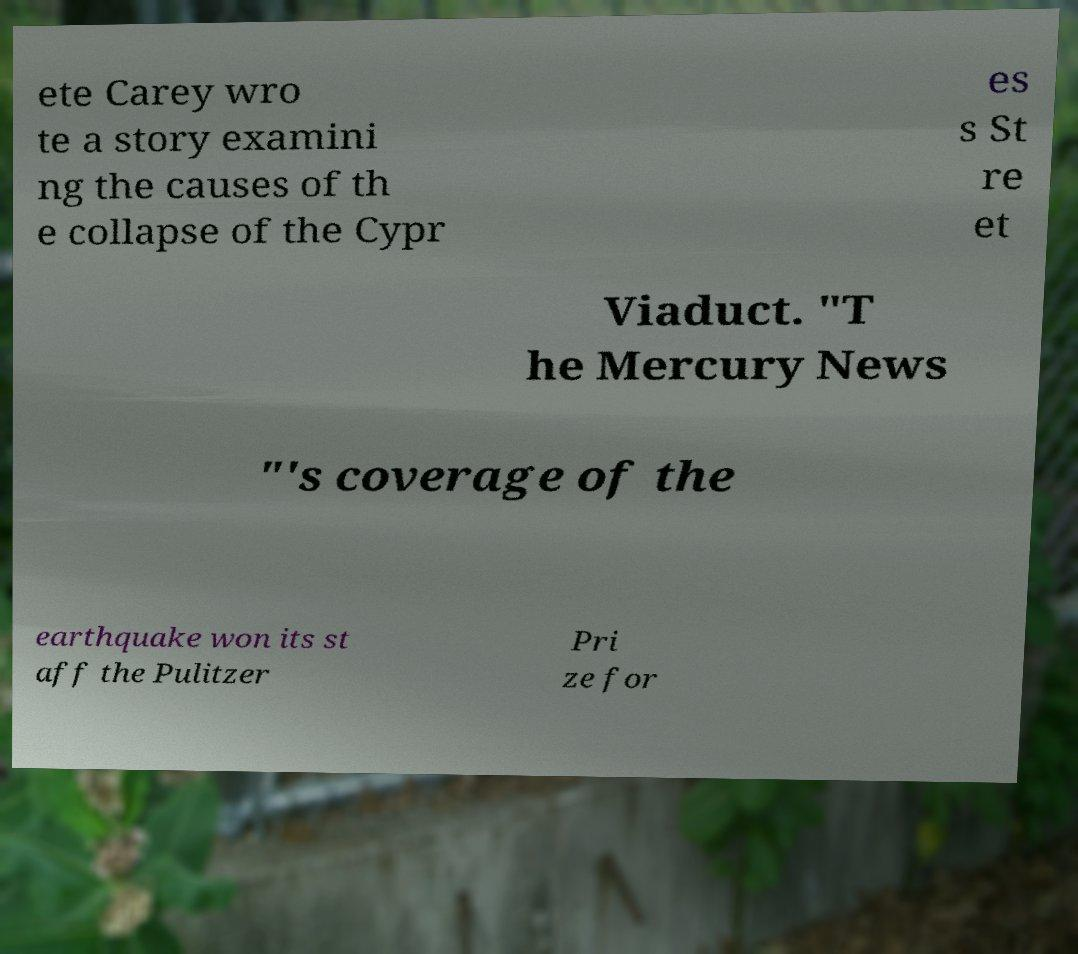Could you extract and type out the text from this image? ete Carey wro te a story examini ng the causes of th e collapse of the Cypr es s St re et Viaduct. "T he Mercury News "'s coverage of the earthquake won its st aff the Pulitzer Pri ze for 